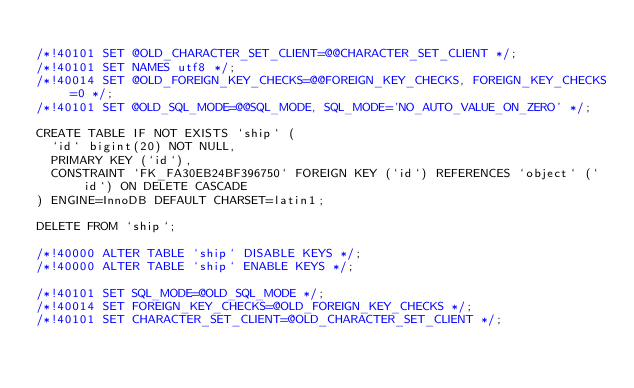Convert code to text. <code><loc_0><loc_0><loc_500><loc_500><_SQL_>
/*!40101 SET @OLD_CHARACTER_SET_CLIENT=@@CHARACTER_SET_CLIENT */;
/*!40101 SET NAMES utf8 */;
/*!40014 SET @OLD_FOREIGN_KEY_CHECKS=@@FOREIGN_KEY_CHECKS, FOREIGN_KEY_CHECKS=0 */;
/*!40101 SET @OLD_SQL_MODE=@@SQL_MODE, SQL_MODE='NO_AUTO_VALUE_ON_ZERO' */;

CREATE TABLE IF NOT EXISTS `ship` (
  `id` bigint(20) NOT NULL,
  PRIMARY KEY (`id`),
  CONSTRAINT `FK_FA30EB24BF396750` FOREIGN KEY (`id`) REFERENCES `object` (`id`) ON DELETE CASCADE
) ENGINE=InnoDB DEFAULT CHARSET=latin1;

DELETE FROM `ship`;
    
/*!40000 ALTER TABLE `ship` DISABLE KEYS */;
/*!40000 ALTER TABLE `ship` ENABLE KEYS */;

/*!40101 SET SQL_MODE=@OLD_SQL_MODE */;
/*!40014 SET FOREIGN_KEY_CHECKS=@OLD_FOREIGN_KEY_CHECKS */;
/*!40101 SET CHARACTER_SET_CLIENT=@OLD_CHARACTER_SET_CLIENT */;
</code> 